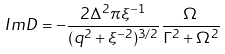Convert formula to latex. <formula><loc_0><loc_0><loc_500><loc_500>I m D = - \frac { 2 \Delta ^ { 2 } \pi \xi ^ { - 1 } } { ( q ^ { 2 } + \xi ^ { - 2 } ) ^ { 3 / 2 } } \frac { \Omega } { \Gamma ^ { 2 } + \Omega ^ { 2 } }</formula> 